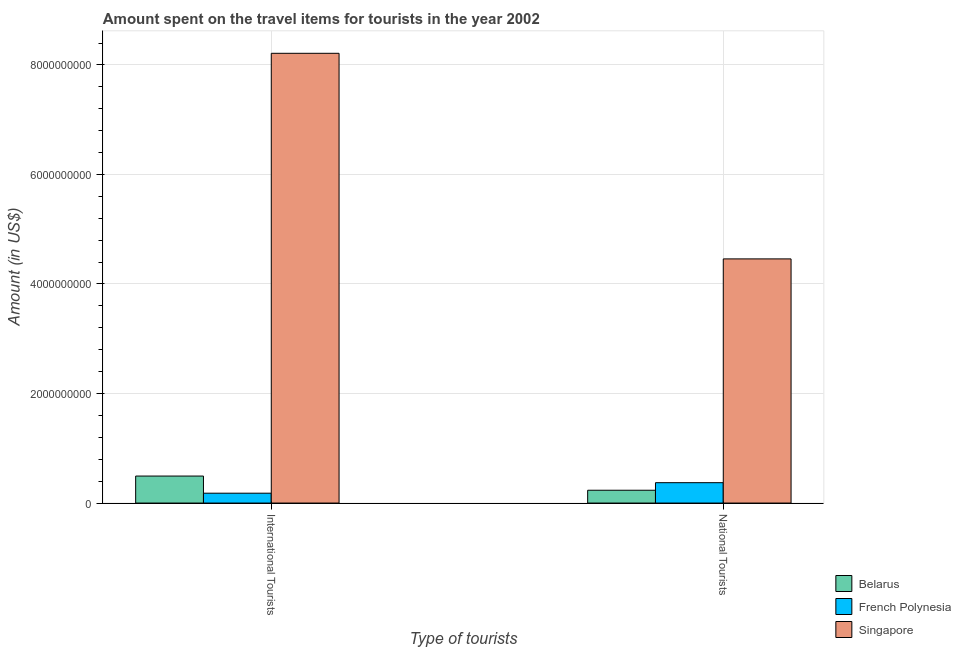Are the number of bars per tick equal to the number of legend labels?
Provide a succinct answer. Yes. Are the number of bars on each tick of the X-axis equal?
Your answer should be compact. Yes. What is the label of the 1st group of bars from the left?
Make the answer very short. International Tourists. What is the amount spent on travel items of international tourists in Singapore?
Provide a short and direct response. 8.21e+09. Across all countries, what is the maximum amount spent on travel items of national tourists?
Ensure brevity in your answer.  4.46e+09. Across all countries, what is the minimum amount spent on travel items of national tourists?
Your answer should be compact. 2.34e+08. In which country was the amount spent on travel items of national tourists maximum?
Your answer should be compact. Singapore. In which country was the amount spent on travel items of international tourists minimum?
Your response must be concise. French Polynesia. What is the total amount spent on travel items of national tourists in the graph?
Your answer should be compact. 5.06e+09. What is the difference between the amount spent on travel items of national tourists in Belarus and that in French Polynesia?
Offer a very short reply. -1.38e+08. What is the difference between the amount spent on travel items of national tourists in French Polynesia and the amount spent on travel items of international tourists in Belarus?
Ensure brevity in your answer.  -1.21e+08. What is the average amount spent on travel items of international tourists per country?
Keep it short and to the point. 2.96e+09. What is the difference between the amount spent on travel items of national tourists and amount spent on travel items of international tourists in Belarus?
Offer a very short reply. -2.59e+08. In how many countries, is the amount spent on travel items of national tourists greater than 3600000000 US$?
Keep it short and to the point. 1. What is the ratio of the amount spent on travel items of national tourists in Singapore to that in Belarus?
Your answer should be very brief. 19.05. Is the amount spent on travel items of international tourists in Singapore less than that in French Polynesia?
Your response must be concise. No. What does the 1st bar from the left in National Tourists represents?
Your response must be concise. Belarus. What does the 2nd bar from the right in International Tourists represents?
Keep it short and to the point. French Polynesia. How many bars are there?
Your answer should be very brief. 6. How many countries are there in the graph?
Your answer should be compact. 3. What is the difference between two consecutive major ticks on the Y-axis?
Make the answer very short. 2.00e+09. Does the graph contain grids?
Offer a terse response. Yes. Where does the legend appear in the graph?
Your response must be concise. Bottom right. How many legend labels are there?
Provide a short and direct response. 3. What is the title of the graph?
Make the answer very short. Amount spent on the travel items for tourists in the year 2002. What is the label or title of the X-axis?
Offer a very short reply. Type of tourists. What is the label or title of the Y-axis?
Provide a short and direct response. Amount (in US$). What is the Amount (in US$) of Belarus in International Tourists?
Make the answer very short. 4.93e+08. What is the Amount (in US$) of French Polynesia in International Tourists?
Make the answer very short. 1.80e+08. What is the Amount (in US$) of Singapore in International Tourists?
Give a very brief answer. 8.21e+09. What is the Amount (in US$) of Belarus in National Tourists?
Your answer should be very brief. 2.34e+08. What is the Amount (in US$) of French Polynesia in National Tourists?
Offer a terse response. 3.72e+08. What is the Amount (in US$) in Singapore in National Tourists?
Offer a terse response. 4.46e+09. Across all Type of tourists, what is the maximum Amount (in US$) in Belarus?
Your response must be concise. 4.93e+08. Across all Type of tourists, what is the maximum Amount (in US$) in French Polynesia?
Provide a short and direct response. 3.72e+08. Across all Type of tourists, what is the maximum Amount (in US$) in Singapore?
Ensure brevity in your answer.  8.21e+09. Across all Type of tourists, what is the minimum Amount (in US$) in Belarus?
Ensure brevity in your answer.  2.34e+08. Across all Type of tourists, what is the minimum Amount (in US$) in French Polynesia?
Keep it short and to the point. 1.80e+08. Across all Type of tourists, what is the minimum Amount (in US$) of Singapore?
Provide a succinct answer. 4.46e+09. What is the total Amount (in US$) of Belarus in the graph?
Give a very brief answer. 7.27e+08. What is the total Amount (in US$) in French Polynesia in the graph?
Your answer should be compact. 5.52e+08. What is the total Amount (in US$) of Singapore in the graph?
Provide a short and direct response. 1.27e+1. What is the difference between the Amount (in US$) in Belarus in International Tourists and that in National Tourists?
Ensure brevity in your answer.  2.59e+08. What is the difference between the Amount (in US$) of French Polynesia in International Tourists and that in National Tourists?
Give a very brief answer. -1.92e+08. What is the difference between the Amount (in US$) in Singapore in International Tourists and that in National Tourists?
Your answer should be compact. 3.75e+09. What is the difference between the Amount (in US$) of Belarus in International Tourists and the Amount (in US$) of French Polynesia in National Tourists?
Provide a succinct answer. 1.21e+08. What is the difference between the Amount (in US$) in Belarus in International Tourists and the Amount (in US$) in Singapore in National Tourists?
Provide a short and direct response. -3.96e+09. What is the difference between the Amount (in US$) in French Polynesia in International Tourists and the Amount (in US$) in Singapore in National Tourists?
Provide a short and direct response. -4.28e+09. What is the average Amount (in US$) in Belarus per Type of tourists?
Keep it short and to the point. 3.64e+08. What is the average Amount (in US$) of French Polynesia per Type of tourists?
Make the answer very short. 2.76e+08. What is the average Amount (in US$) in Singapore per Type of tourists?
Provide a succinct answer. 6.34e+09. What is the difference between the Amount (in US$) in Belarus and Amount (in US$) in French Polynesia in International Tourists?
Make the answer very short. 3.13e+08. What is the difference between the Amount (in US$) of Belarus and Amount (in US$) of Singapore in International Tourists?
Provide a succinct answer. -7.72e+09. What is the difference between the Amount (in US$) of French Polynesia and Amount (in US$) of Singapore in International Tourists?
Provide a succinct answer. -8.03e+09. What is the difference between the Amount (in US$) of Belarus and Amount (in US$) of French Polynesia in National Tourists?
Provide a succinct answer. -1.38e+08. What is the difference between the Amount (in US$) in Belarus and Amount (in US$) in Singapore in National Tourists?
Keep it short and to the point. -4.22e+09. What is the difference between the Amount (in US$) of French Polynesia and Amount (in US$) of Singapore in National Tourists?
Give a very brief answer. -4.09e+09. What is the ratio of the Amount (in US$) of Belarus in International Tourists to that in National Tourists?
Ensure brevity in your answer.  2.11. What is the ratio of the Amount (in US$) of French Polynesia in International Tourists to that in National Tourists?
Your answer should be compact. 0.48. What is the ratio of the Amount (in US$) of Singapore in International Tourists to that in National Tourists?
Give a very brief answer. 1.84. What is the difference between the highest and the second highest Amount (in US$) of Belarus?
Provide a succinct answer. 2.59e+08. What is the difference between the highest and the second highest Amount (in US$) of French Polynesia?
Offer a terse response. 1.92e+08. What is the difference between the highest and the second highest Amount (in US$) of Singapore?
Provide a short and direct response. 3.75e+09. What is the difference between the highest and the lowest Amount (in US$) in Belarus?
Give a very brief answer. 2.59e+08. What is the difference between the highest and the lowest Amount (in US$) of French Polynesia?
Offer a very short reply. 1.92e+08. What is the difference between the highest and the lowest Amount (in US$) in Singapore?
Your response must be concise. 3.75e+09. 